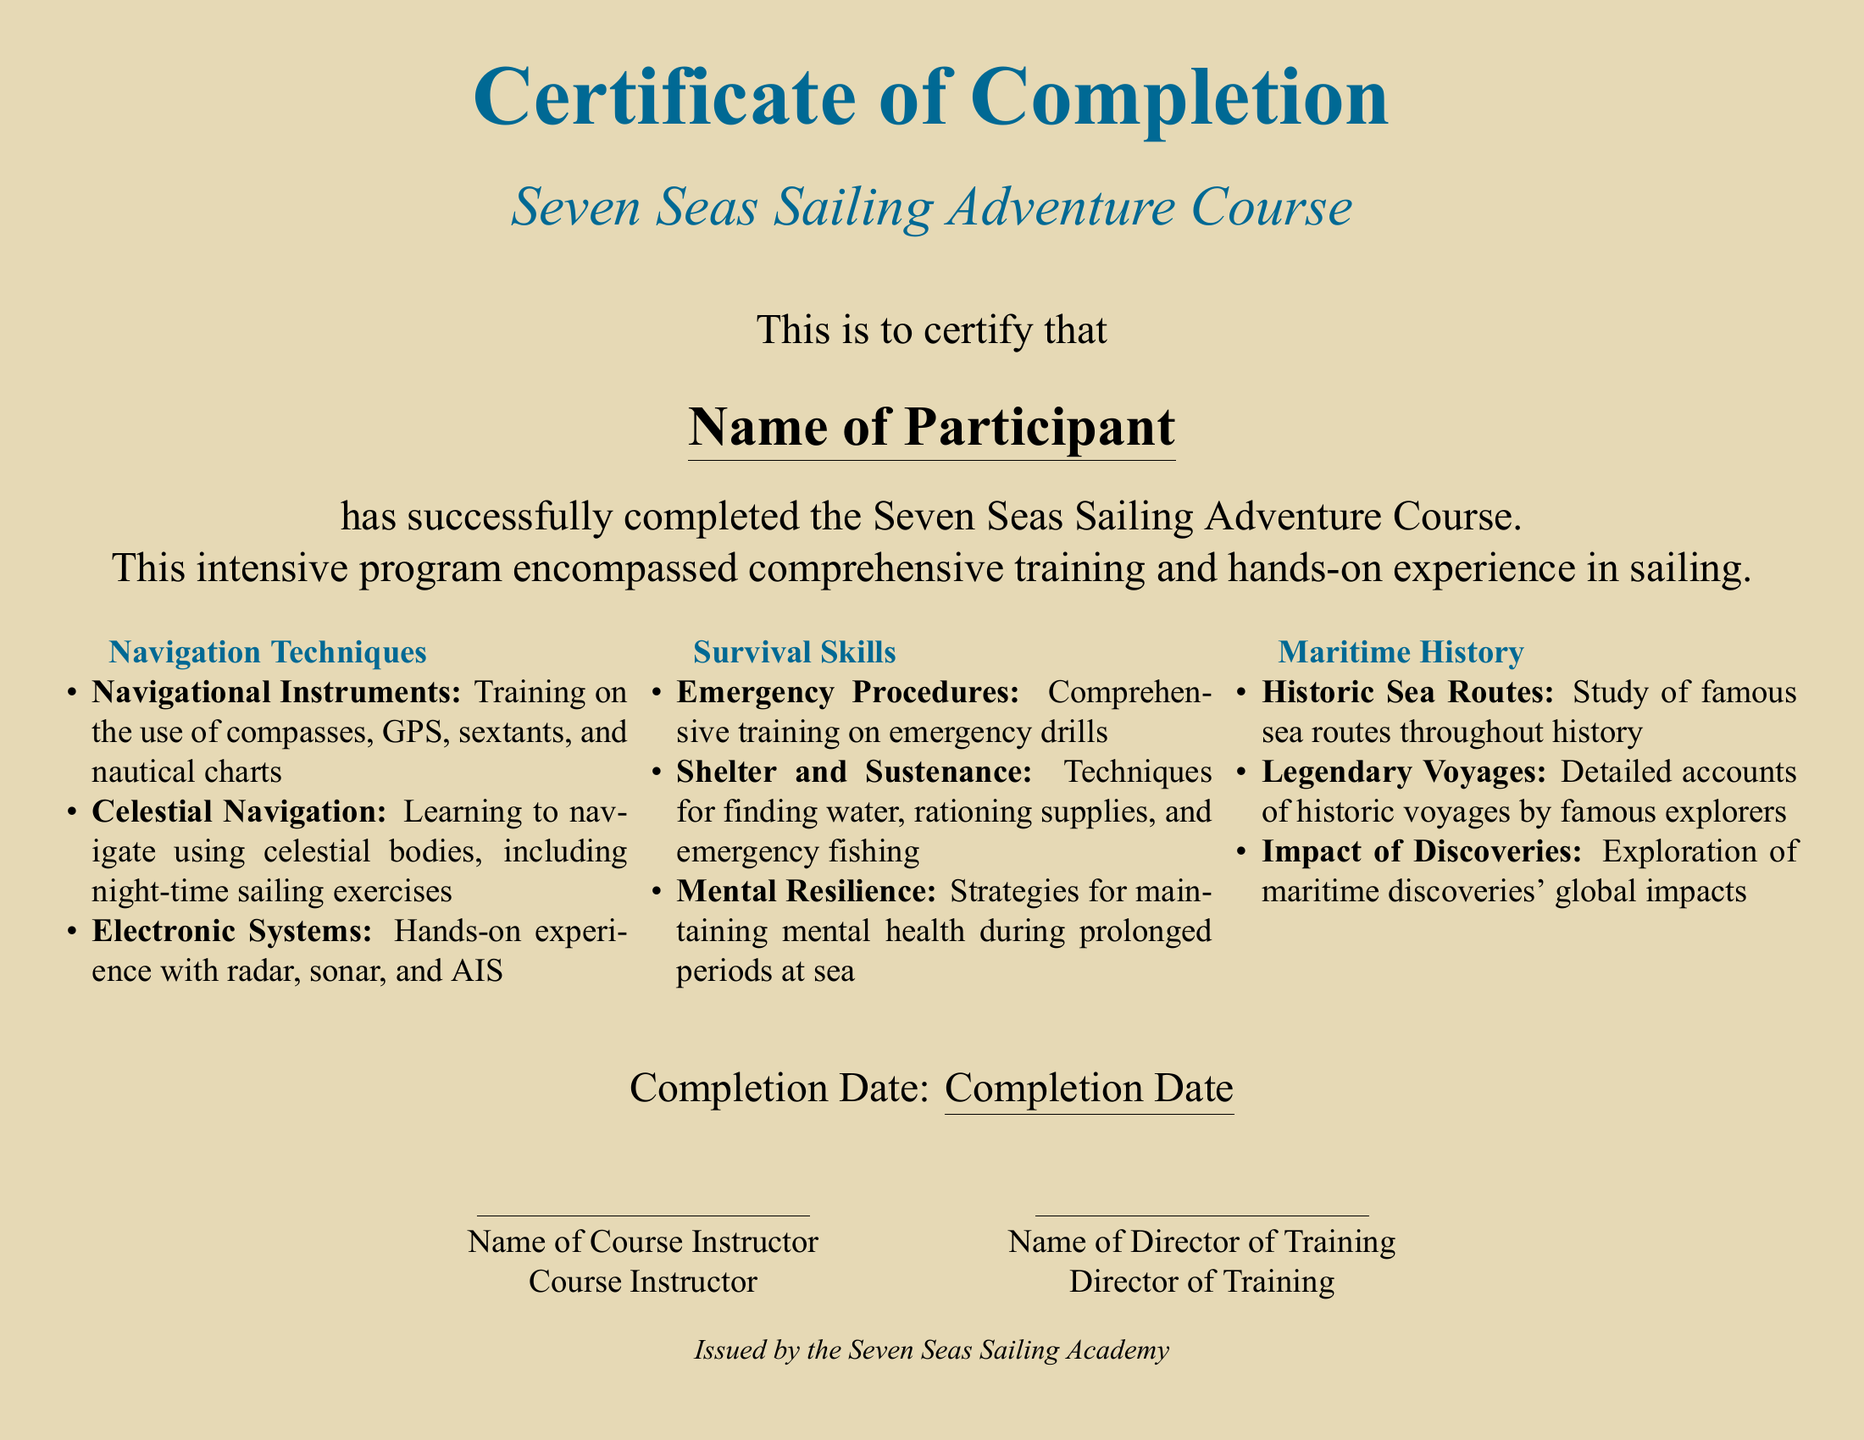What is the title of the course? The title of the course is explicitly stated at the top of the document.
Answer: Seven Seas Sailing Adventure Course Who is the participant mentioned in the certificate? The document has a placeholder for the participant's name.
Answer: Name of Participant What skill related to navigation is taught during the course? Specific navigation skills are listed, indicating what was trained.
Answer: Celestial Navigation What is one of the survival skills covered in the course? The survival skills section outlines specific techniques taught in the program.
Answer: Emergency Procedures What date is provided for course completion? The completion date is indicated in a designated area within the document.
Answer: Completion Date Which maritime history topic covers famous explorers? The document details different topics in maritime history, one of which specifically discusses explorers.
Answer: Legendary Voyages How many sections are there in the course content? The course content is divided into three distinct sections.
Answer: Three Who is one of the individuals that provide their name on the certificate? The document lists roles with space for names, indicating who endorses the completion.
Answer: Name of Course Instructor What color is the document background? The background color of the document is explicitly defined.
Answer: Sandy Beige 